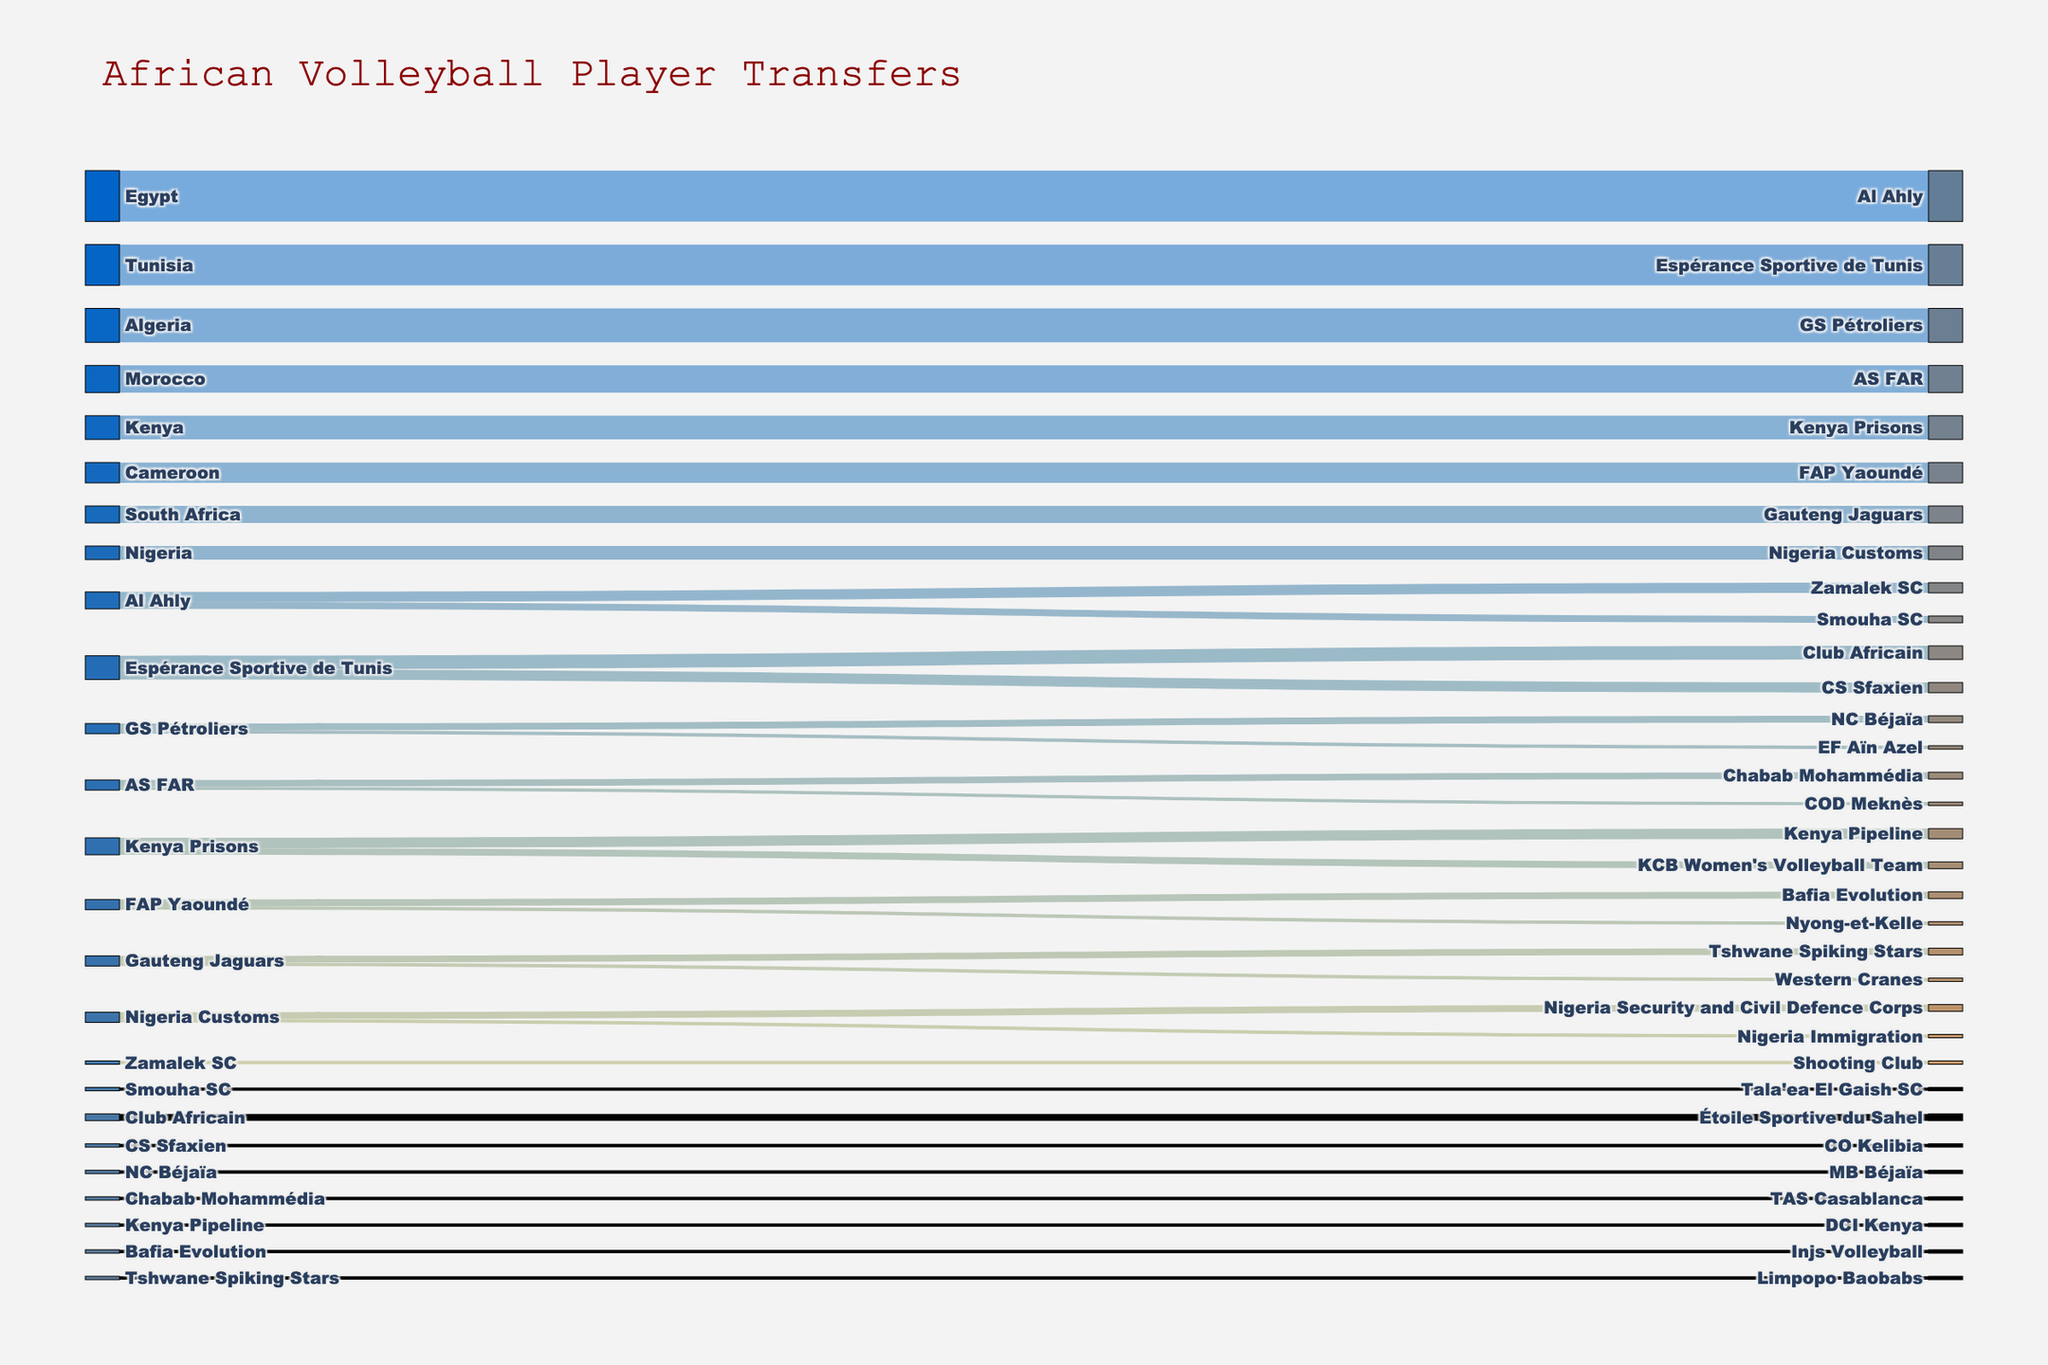Which team has the highest number of player transfers from its country? We can observe that Al Ahly received 15 players from Egypt, which is the highest value on the figure.
Answer: Al Ahly Which team has the lowest number of player transfers from its country? By examining the figure, we see that GS Pétroliers received 1 player from EF Aïn Azel and Kenya Pipeline received 1 player from DCI Kenya. Both have the lowest transfers.
Answer: GS Pétroliers, Kenya Pipeline What is the total number of player transfers from Egypt? Adding up the values of transfers originating from Egypt (Al Ahly: 15), we get a total of 15.
Answer: 15 Compare the number of player transfers to Espérance Sportive de Tunis and Al Ahly. Which received more? Espérance Sportive de Tunis received 12 players, whereas Al Ahly received 15 players. Thus, Al Ahly received more.
Answer: Al Ahly What is the total number of player transfers for Kenya's teams? Kenya's teams are Kenya Prisons (7), Kenya Pipeline (3), and KCB Women's Volleyball Team (2). Adding these gives 7 + 3 + 2 = 12.
Answer: 12 What are the names of the teams that players from GS Pétroliers transfer to, and how many players move to each? Players from GS Pétroliers transfer to NC Béjaïa (2) and EF Aïn Azel (1).
Answer: NC Béjaïa, EF Aïn Azel How many teams receive player transfers from Al Ahly, and what are they? Players from Al Ahly transfer to Zamalek SC (3) and Smouha SC (2), making a total of 2 teams.
Answer: Zamalek SC, Smouha SC Compare the player transfers between Kenya's clubs and South Africa's clubs. Which country has more internal transfers? Kenya has transfers to Kenya Pipeline (3) and KCB Women's Volleyball Team (2), summing to 5. South Africa has transfers to Tshwane Spiking Stars (2) and Western Cranes (1), summing to 3. Thus, Kenya has more internal transfers.
Answer: Kenya What is the total number of player transfers from Tunisia? Total transfers from Tunisia are to Espérance Sportive de Tunis (12), Club Africain (4), and CS Sfaxien (3). Adding these gives 12 + 4 + 3 = 19.
Answer: 19 